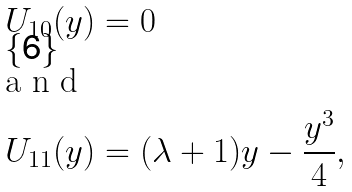Convert formula to latex. <formula><loc_0><loc_0><loc_500><loc_500>U _ { 1 0 } ( y ) & = 0 \intertext { a n d } U _ { 1 1 } ( y ) & = ( \lambda + 1 ) y - \frac { y ^ { 3 } } 4 ,</formula> 